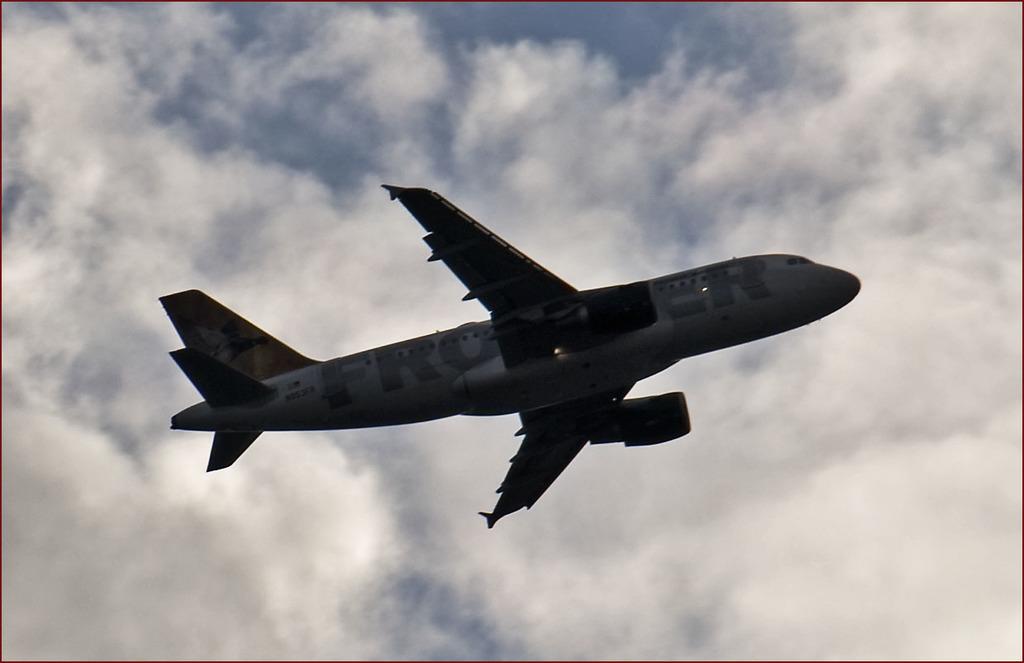What airline is this?
Give a very brief answer. Frontier. 